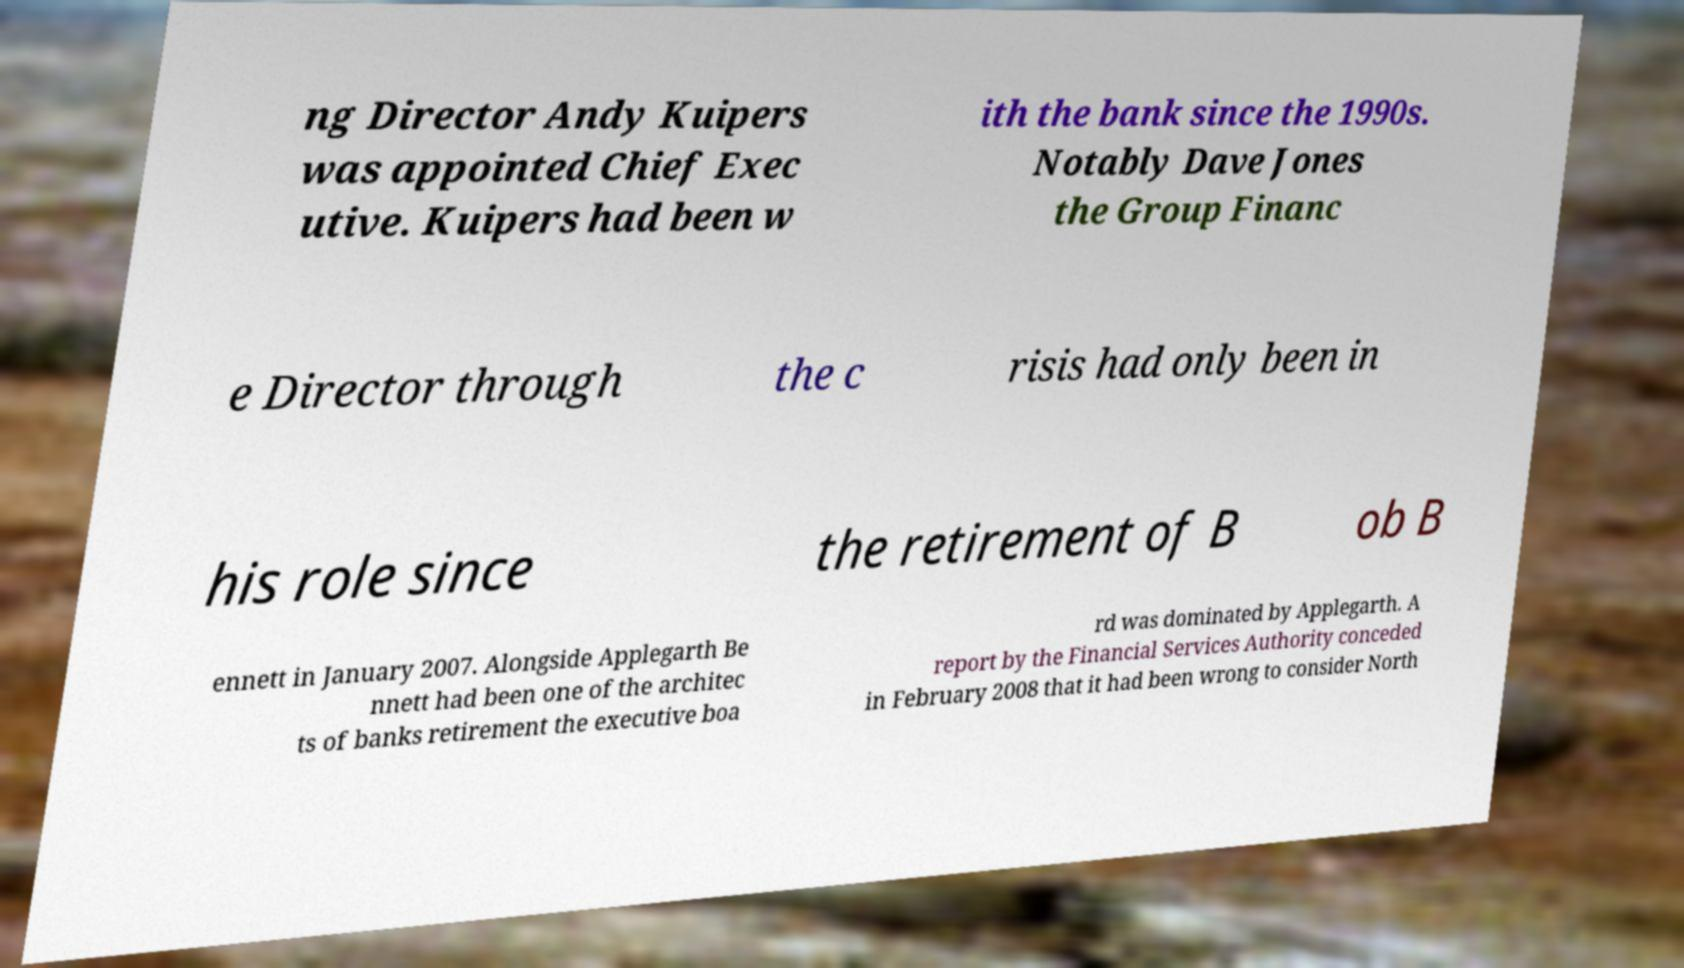Can you read and provide the text displayed in the image?This photo seems to have some interesting text. Can you extract and type it out for me? ng Director Andy Kuipers was appointed Chief Exec utive. Kuipers had been w ith the bank since the 1990s. Notably Dave Jones the Group Financ e Director through the c risis had only been in his role since the retirement of B ob B ennett in January 2007. Alongside Applegarth Be nnett had been one of the architec ts of banks retirement the executive boa rd was dominated by Applegarth. A report by the Financial Services Authority conceded in February 2008 that it had been wrong to consider North 